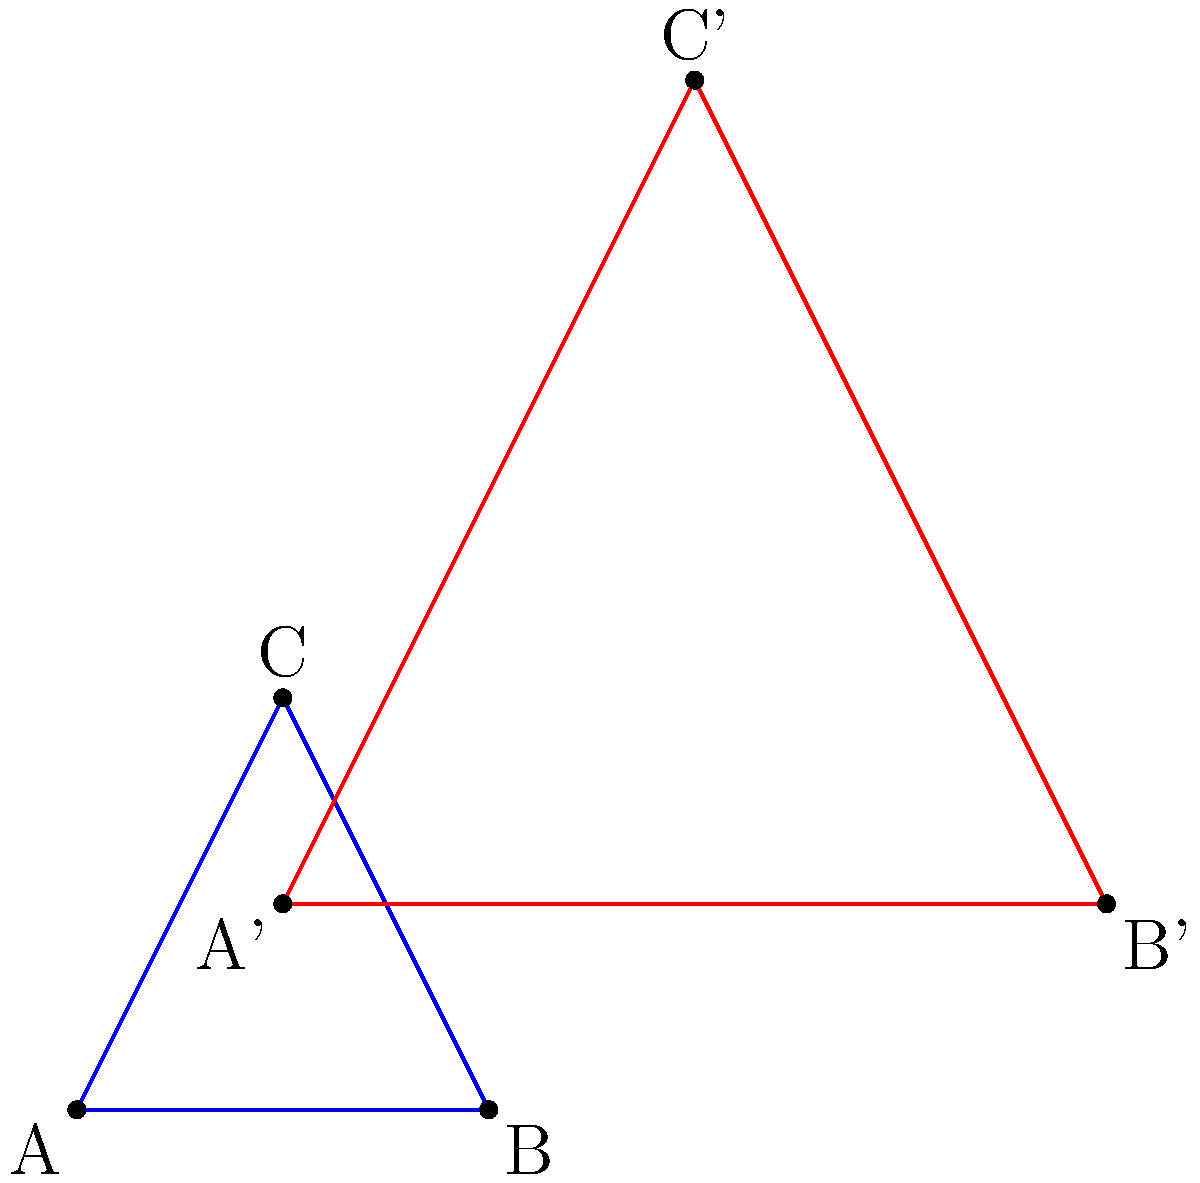As a freelance graphic designer specializing in interactive diagrams, you're tasked with creating a visualization of geometric transformations. Given the blue triangle ABC and its transformed red counterpart A'B'C', determine the transformation matrix that maps ABC to A'B'C'. What is the resulting 2x2 transformation matrix? To find the transformation matrix, we need to follow these steps:

1) First, we need to identify the coordinates of the original and transformed triangles:
   A(1,1), B(3,1), C(2,3)
   A'(2,2), B'(6,2), C'(4,6)

2) The transformation matrix we're looking for will be in the form:
   $$\begin{pmatrix} a & b \\ c & d \end{pmatrix}$$

3) We can set up a system of equations using the coordinates:
   $$\begin{pmatrix} a & b \\ c & d \end{pmatrix} \begin{pmatrix} 1 \\ 1 \end{pmatrix} = \begin{pmatrix} 2 \\ 2 \end{pmatrix}$$
   $$\begin{pmatrix} a & b \\ c & d \end{pmatrix} \begin{pmatrix} 3 \\ 1 \end{pmatrix} = \begin{pmatrix} 6 \\ 2 \end{pmatrix}$$

4) From these, we can derive:
   $a + b = 2$ (1)
   $c + d = 2$ (2)
   $3a + b = 6$ (3)
   $3c + d = 2$ (4)

5) Subtracting (1) from (3):
   $2a = 4$
   $a = 2$

6) Substituting this back into (1):
   $2 + b = 2$
   $b = 0$

7) Subtracting (2) from (4):
   $2c = 0$
   $c = 0$

8) Substituting this back into (2):
   $d = 2$

Therefore, the transformation matrix is:
$$\begin{pmatrix} 2 & 0 \\ 0 & 2 \end{pmatrix}$$

This matrix represents a scaling transformation that doubles the size of the original triangle in both x and y directions.
Answer: $$\begin{pmatrix} 2 & 0 \\ 0 & 2 \end{pmatrix}$$ 